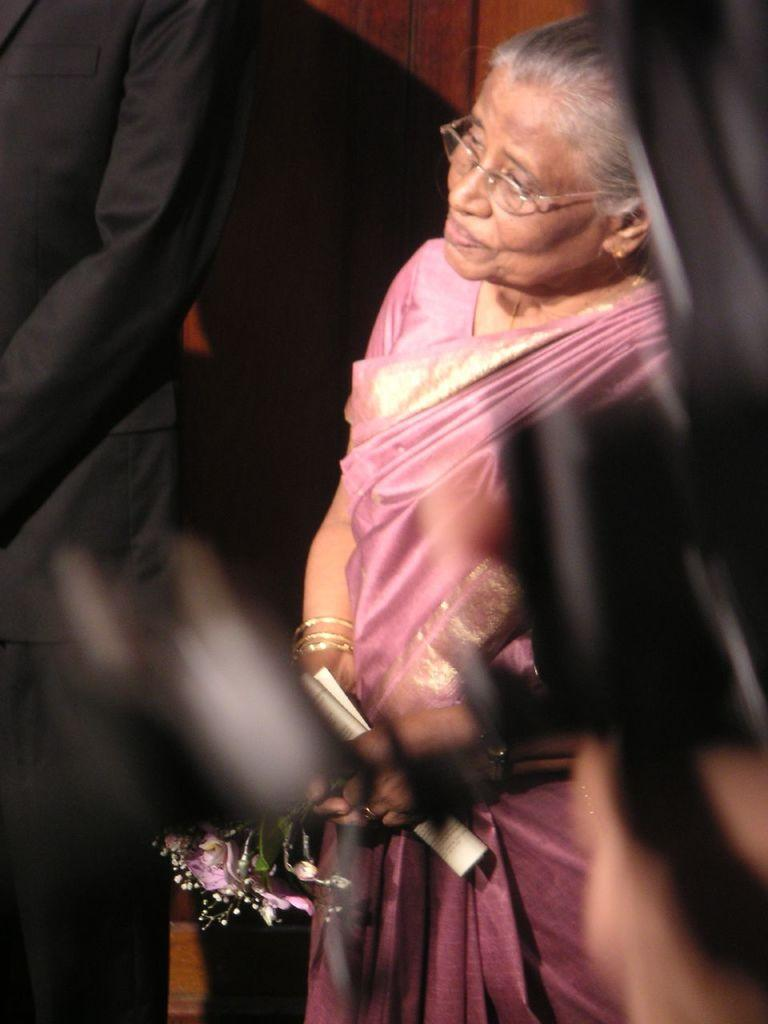Who is present in the image? There is a woman in the image. What is the woman holding in her hand? The woman is holding paper in her hand. Can you describe the person standing beside the woman? There appears to be a person standing beside the woman, but no specific details are provided. What type of surface can be seen in the background of the image? There is a wooden surface in the background of the image. What type of turkey can be seen in the image? There is no turkey present in the image. How does the woman use the scissors in the image? There are no scissors present in the image, so it is not possible to answer that question. 